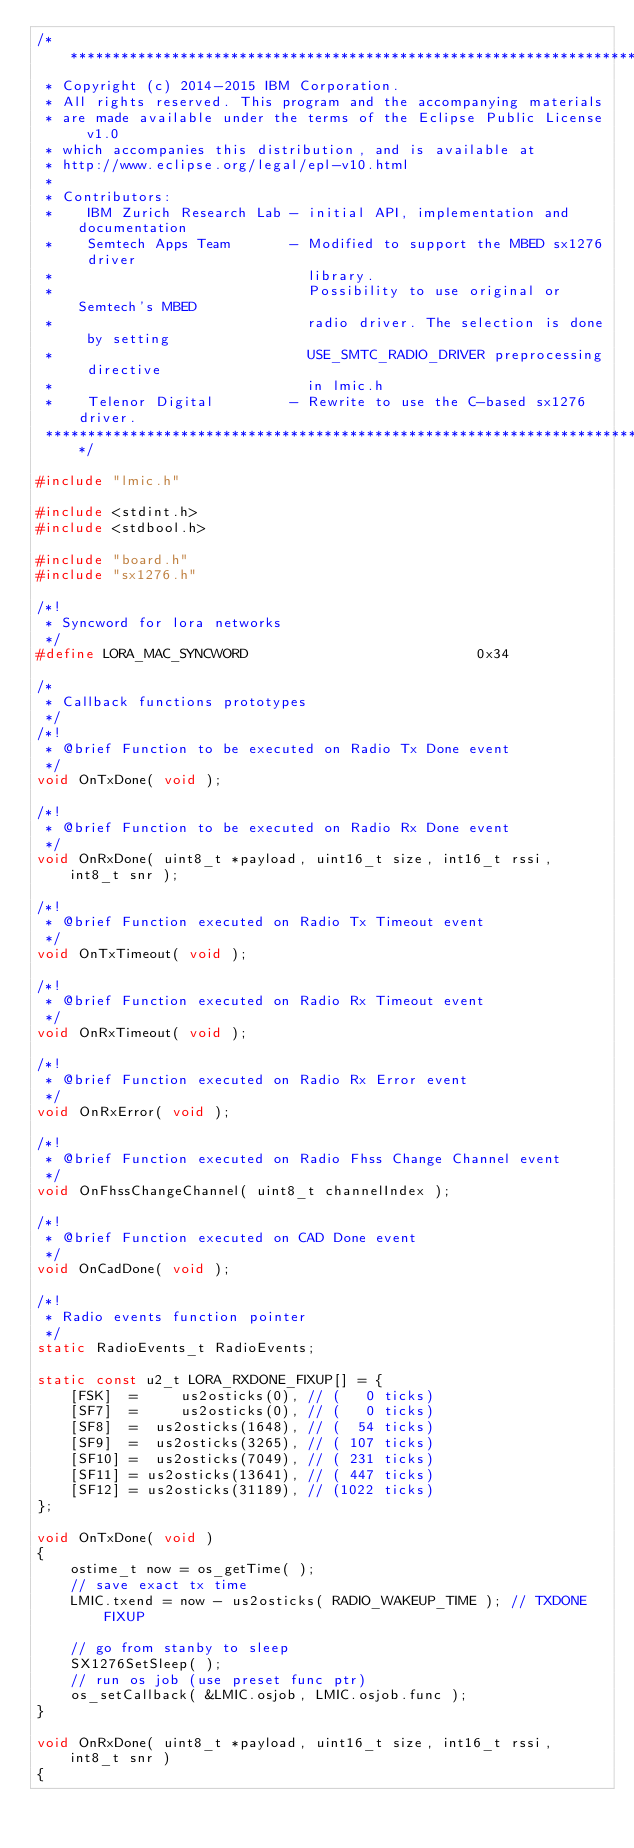Convert code to text. <code><loc_0><loc_0><loc_500><loc_500><_C_>/*******************************************************************************
 * Copyright (c) 2014-2015 IBM Corporation.
 * All rights reserved. This program and the accompanying materials
 * are made available under the terms of the Eclipse Public License v1.0
 * which accompanies this distribution, and is available at
 * http://www.eclipse.org/legal/epl-v10.html
 *
 * Contributors:
 *    IBM Zurich Research Lab - initial API, implementation and documentation
 *    Semtech Apps Team       - Modified to support the MBED sx1276 driver
 *                              library.
 *                              Possibility to use original or Semtech's MBED
 *                              radio driver. The selection is done by setting
 *                              USE_SMTC_RADIO_DRIVER preprocessing directive
 *                              in lmic.h
 *    Telenor Digital         - Rewrite to use the C-based sx1276 driver.
 *******************************************************************************/

#include "lmic.h"

#include <stdint.h>
#include <stdbool.h>

#include "board.h"
#include "sx1276.h"

/*!
 * Syncword for lora networks
 */
#define LORA_MAC_SYNCWORD                           0x34

/*
 * Callback functions prototypes
 */
/*!
 * @brief Function to be executed on Radio Tx Done event
 */
void OnTxDone( void );

/*!
 * @brief Function to be executed on Radio Rx Done event
 */
void OnRxDone( uint8_t *payload, uint16_t size, int16_t rssi, int8_t snr );

/*!
 * @brief Function executed on Radio Tx Timeout event
 */
void OnTxTimeout( void );

/*!
 * @brief Function executed on Radio Rx Timeout event
 */
void OnRxTimeout( void );

/*!
 * @brief Function executed on Radio Rx Error event
 */
void OnRxError( void );

/*!
 * @brief Function executed on Radio Fhss Change Channel event
 */
void OnFhssChangeChannel( uint8_t channelIndex );

/*!
 * @brief Function executed on CAD Done event
 */
void OnCadDone( void );

/*!
 * Radio events function pointer
 */
static RadioEvents_t RadioEvents;

static const u2_t LORA_RXDONE_FIXUP[] = {
    [FSK]  =     us2osticks(0), // (   0 ticks)
    [SF7]  =     us2osticks(0), // (   0 ticks)
    [SF8]  =  us2osticks(1648), // (  54 ticks)
    [SF9]  =  us2osticks(3265), // ( 107 ticks)
    [SF10] =  us2osticks(7049), // ( 231 ticks)
    [SF11] = us2osticks(13641), // ( 447 ticks)
    [SF12] = us2osticks(31189), // (1022 ticks)
};

void OnTxDone( void )
{
    ostime_t now = os_getTime( );
    // save exact tx time
    LMIC.txend = now - us2osticks( RADIO_WAKEUP_TIME ); // TXDONE FIXUP

    // go from stanby to sleep
    SX1276SetSleep( );
    // run os job (use preset func ptr)
    os_setCallback( &LMIC.osjob, LMIC.osjob.func );
}

void OnRxDone( uint8_t *payload, uint16_t size, int16_t rssi, int8_t snr )
{</code> 